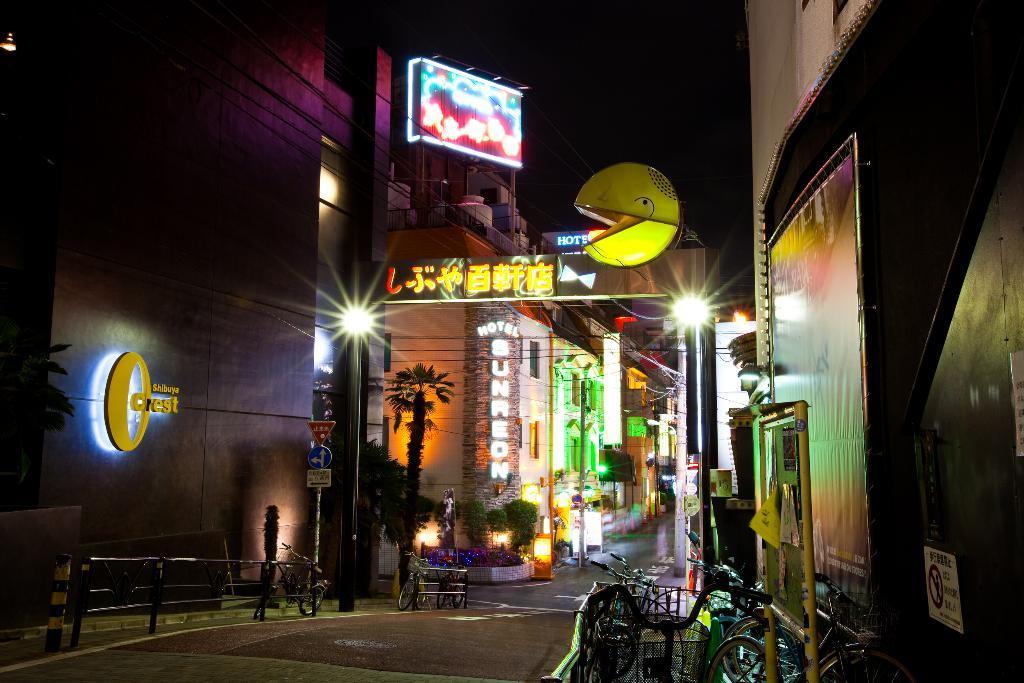Could you give a brief overview of what you see in this image? In this image I can see the road. to the side of the road there is a railing and the bicycles. I can also see some boards to the pole. To the side there are trees and the buildings. I can also see the light poles to the side. In the back there are boards to the building and the sky. 